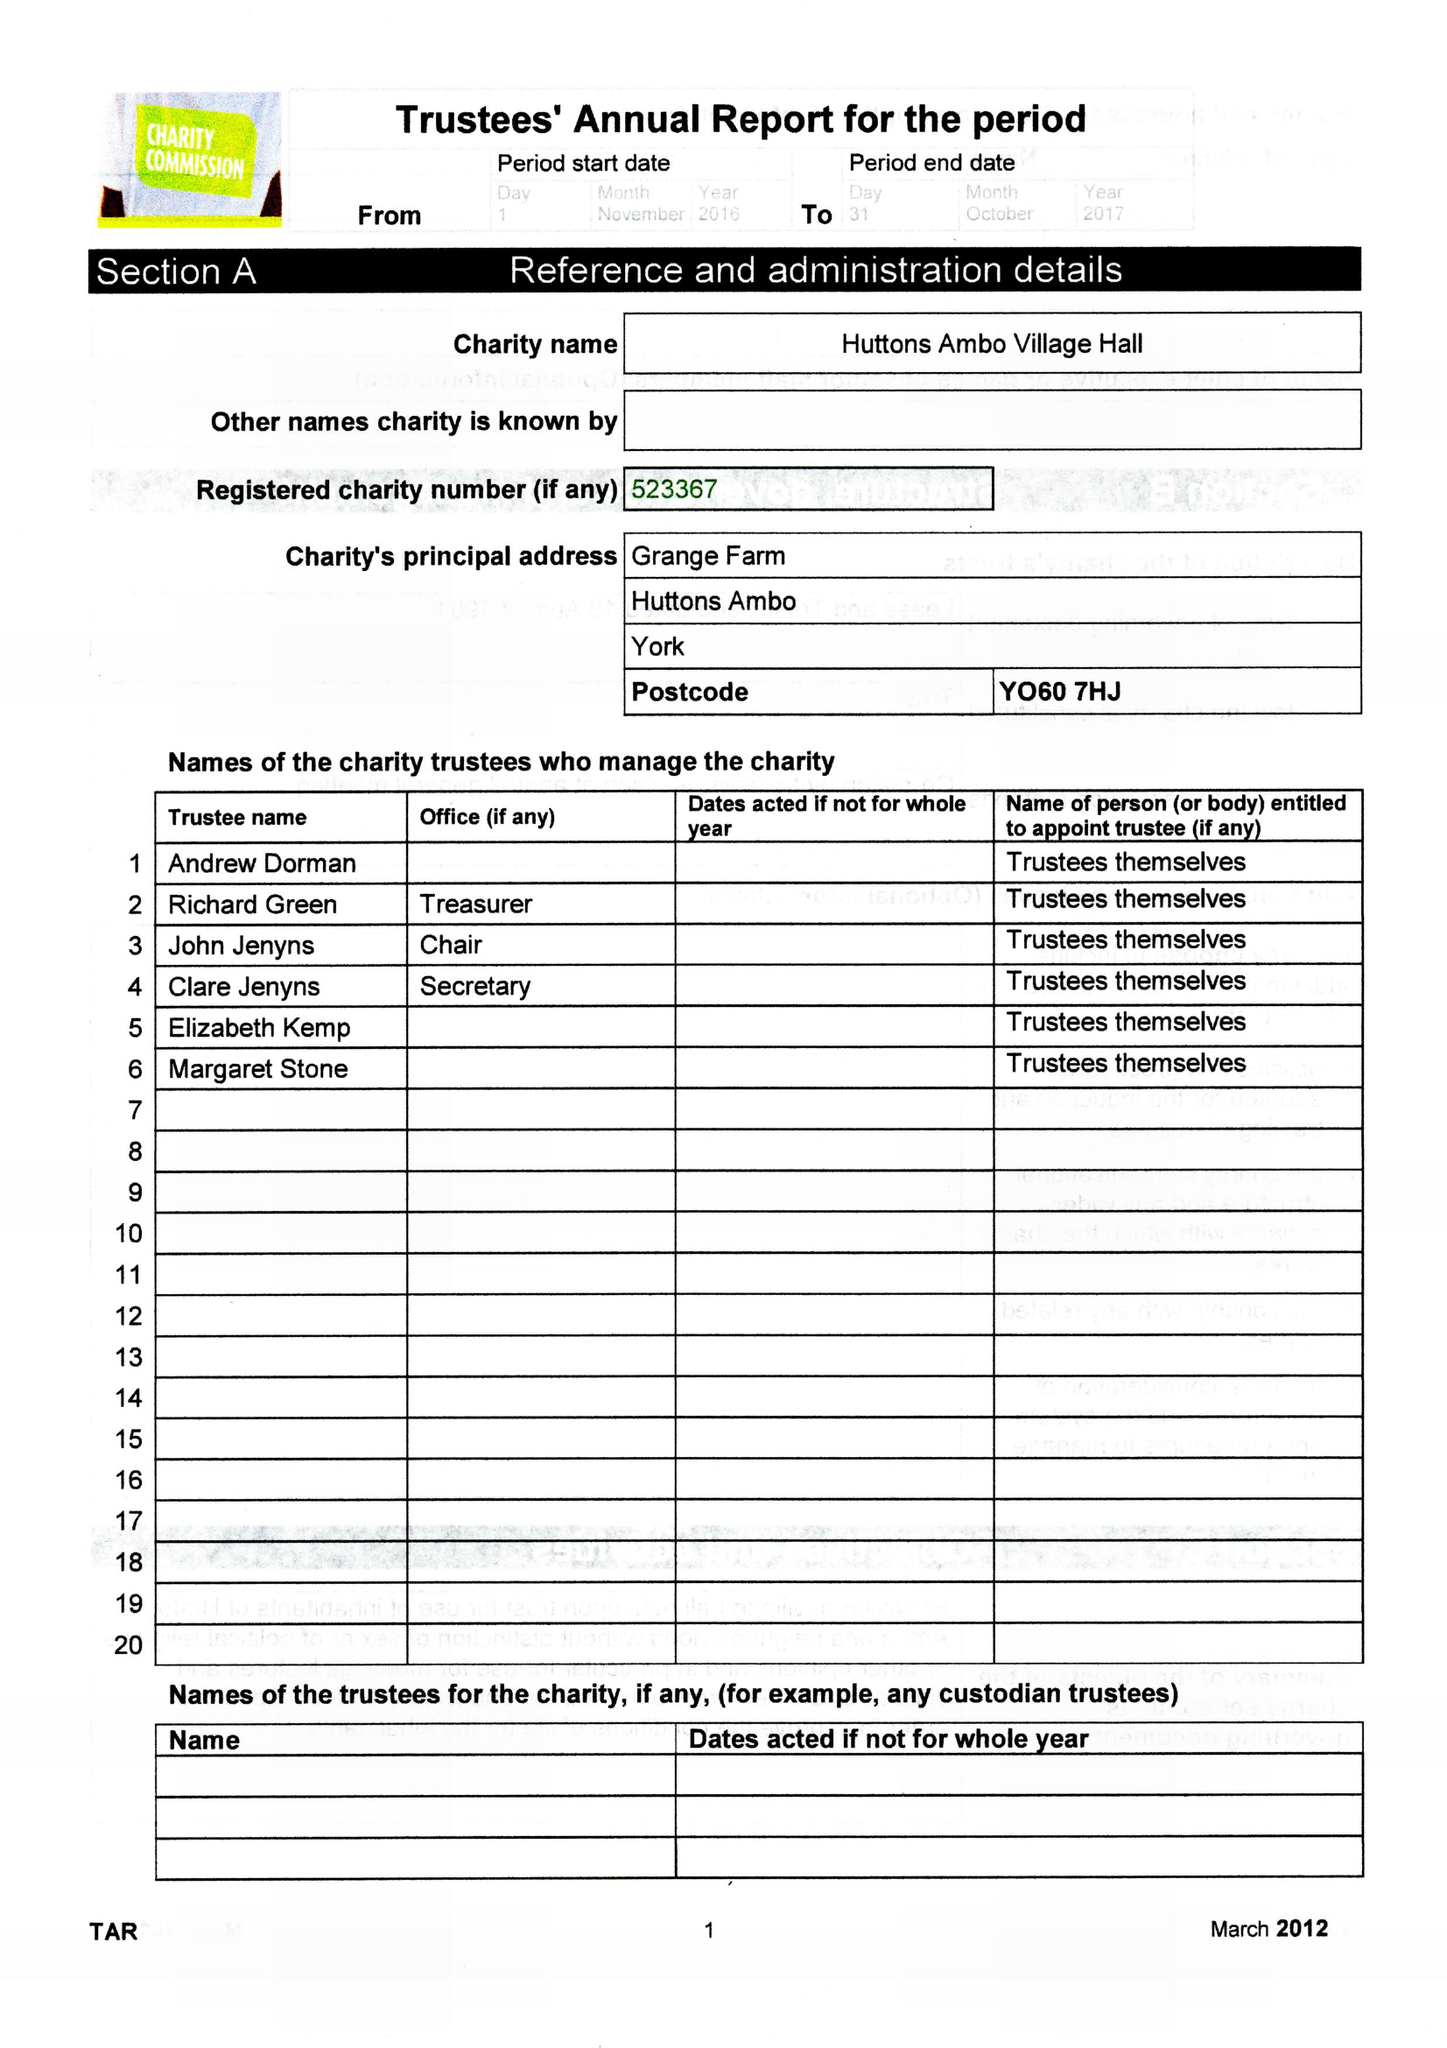What is the value for the income_annually_in_british_pounds?
Answer the question using a single word or phrase. 188606.00 